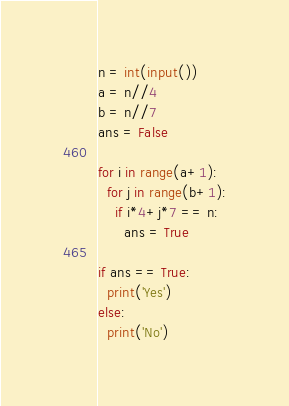<code> <loc_0><loc_0><loc_500><loc_500><_Python_>n = int(input())
a = n//4
b = n//7
ans = False

for i in range(a+1):
  for j in range(b+1):
    if i*4+j*7 == n:
      ans = True

if ans == True:
  print('Yes')
else:
  print('No')</code> 